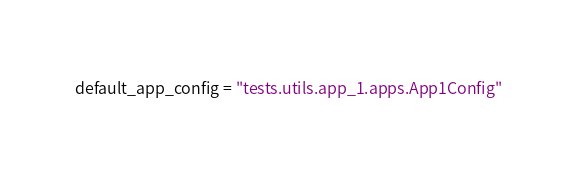<code> <loc_0><loc_0><loc_500><loc_500><_Python_>default_app_config = "tests.utils.app_1.apps.App1Config"
</code> 